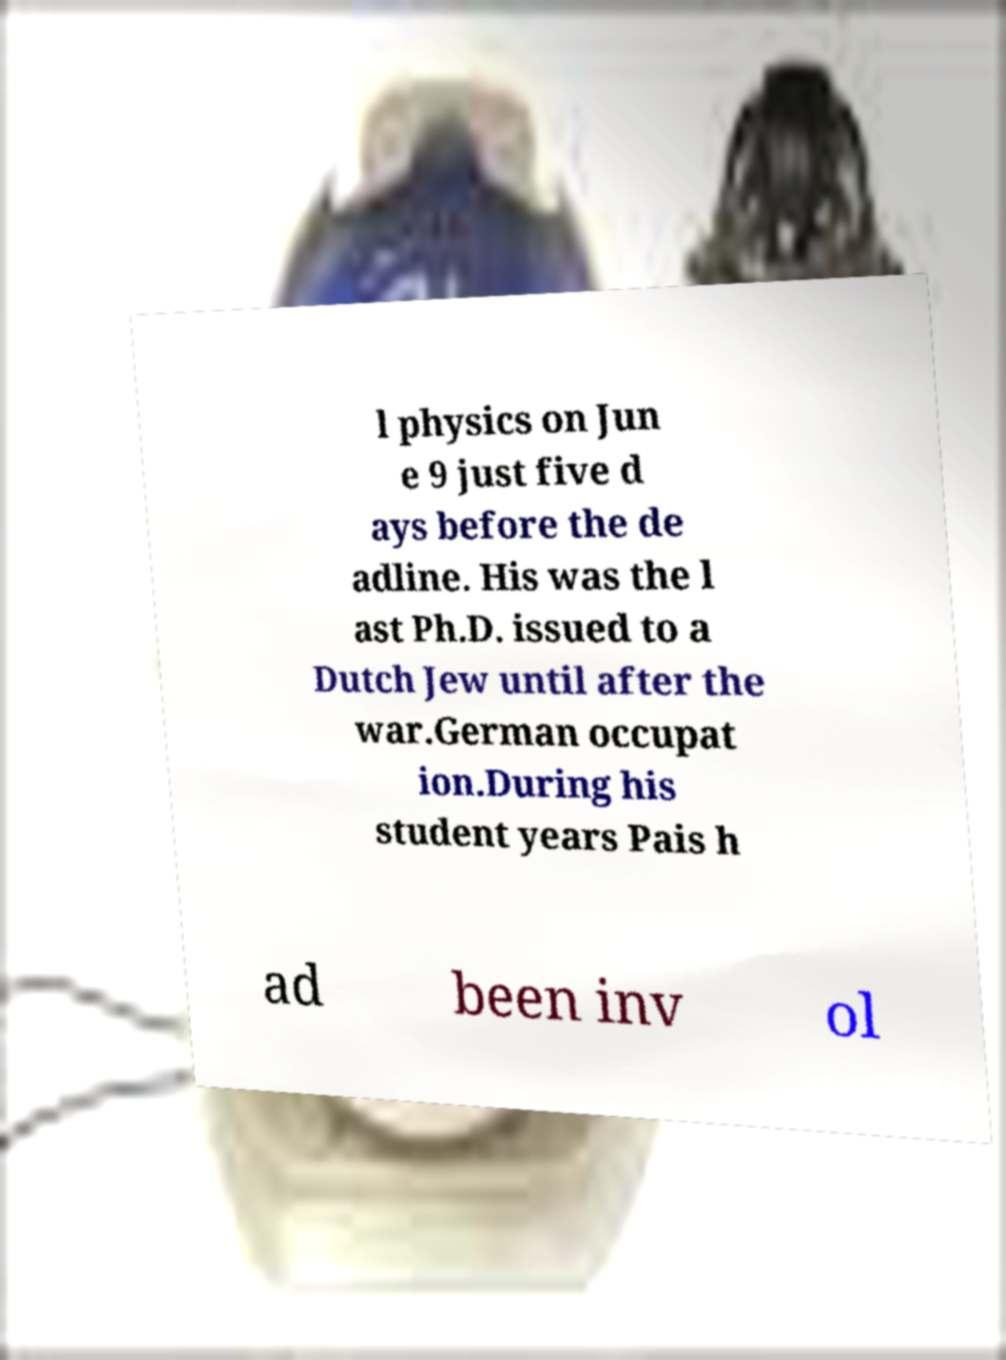Please read and relay the text visible in this image. What does it say? l physics on Jun e 9 just five d ays before the de adline. His was the l ast Ph.D. issued to a Dutch Jew until after the war.German occupat ion.During his student years Pais h ad been inv ol 